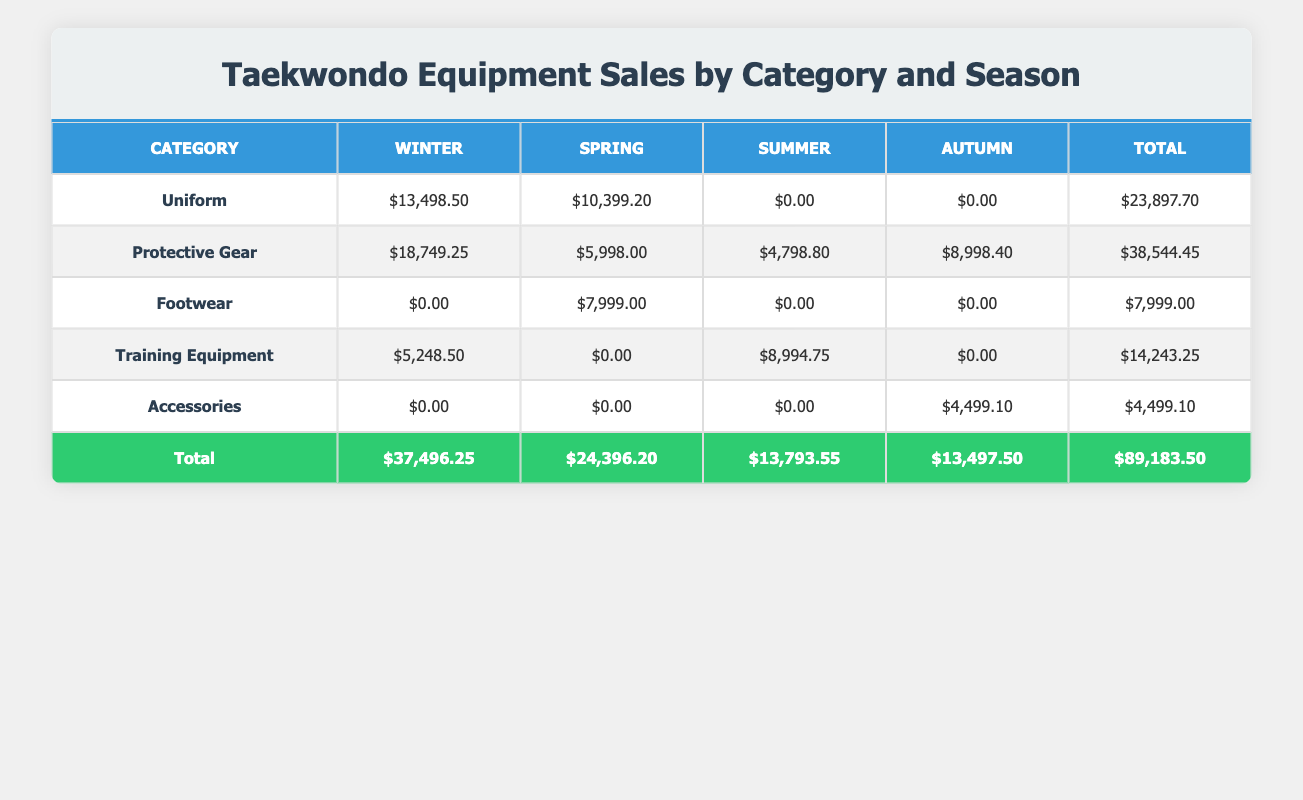What is the total revenue from Uniform sales? According to the table, the total revenue from Uniform sales is $23,897.70. This value is provided in the Total column under the Uniform category.
Answer: $23,897.70 Which category had the highest sales in Winter? The Protective Gear category had the highest sales in Winter, totaling $18,749.25, which is the highest amount in the Winter column.
Answer: Protective Gear What was the total quantity sold for Training Equipment across all seasons? To find the total quantity sold for Training Equipment, we sum the quantities sold in each season: 25 (Summer) + 150 (Winter) = 175. As there are no sales in Spring and Autumn, the total is 175.
Answer: 175 Is the total revenue from Summer sales greater than from Autumn sales? First, we check the total revenue for each season. Summer revenue totals $13,793.55 while Autumn totals $13,497.50. Since $13,793.55 is greater than $13,497.50, the answer is yes.
Answer: Yes Which season generated the least total revenue overall? The revenues for each season are: Winter: $37,496.25, Spring: $24,396.20, Summer: $13,793.55, Autumn: $13,497.50. The least revenue is in Summer, which totalled $13,793.55.
Answer: Summer What category had no sales in the Summer season? By examining the table, we see that the Uniform and Accessories categories had $0.00 sales in Summer, as indicated in their respective columns.
Answer: Uniform, Accessories How much did Protective Gear earn in Autumn? The Protective Gear category earned $8,998.40 in Autumn, which is the value listed in the Autumn column.
Answer: $8,998.40 What is the average revenue generated by category in Spring? To find the average revenue for Spring, we take the total revenue for each category in that season and divide it by the number of categories with sales. There are three categories with sales: Protective Gear ($5,998.00), Footwear ($7,999.00), and Uniform ($10,399.20). The total is $24,396.20 and the average is $24,396.20 / 3, which equals $8,132.07.
Answer: $8,132.07 According to the table, did any category have revenue in every season? By reviewing the table, it is clear that no single category had revenue in all four seasons. Tabs reveal that categories generated revenue across different seasons but not consistently in all of them.
Answer: No 